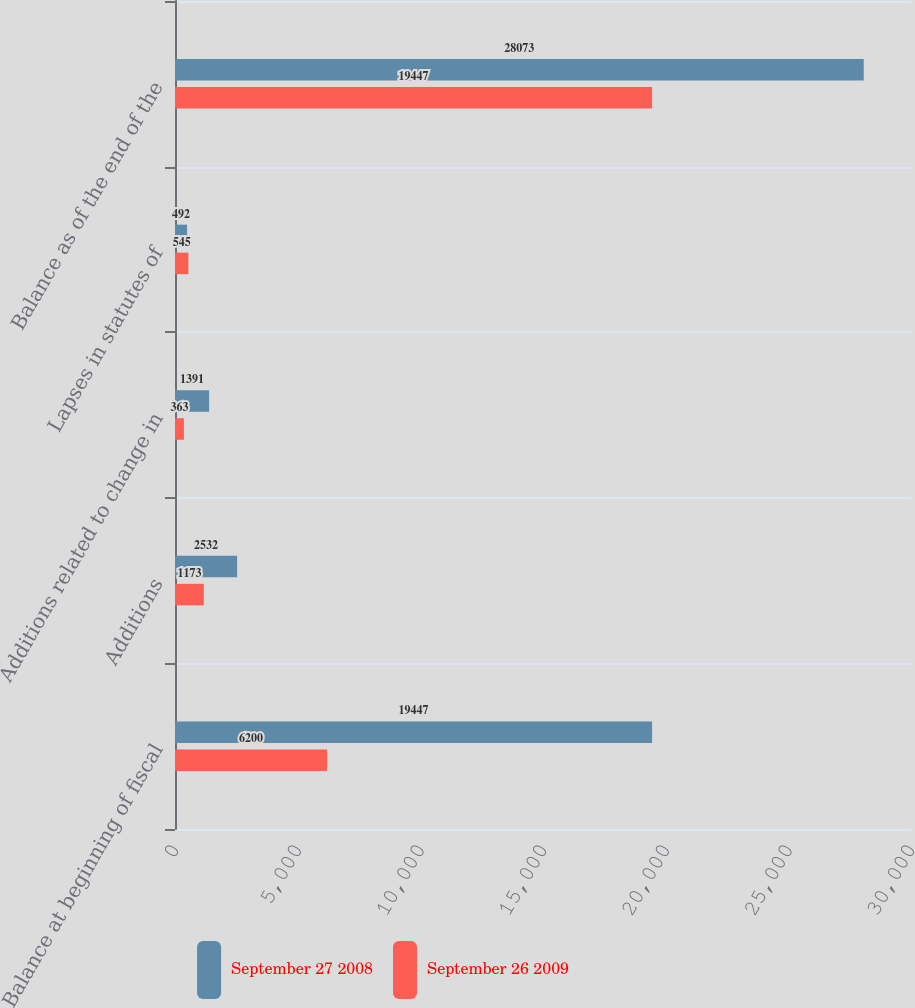Convert chart. <chart><loc_0><loc_0><loc_500><loc_500><stacked_bar_chart><ecel><fcel>Balance at beginning of fiscal<fcel>Additions<fcel>Additions related to change in<fcel>Lapses in statutes of<fcel>Balance as of the end of the<nl><fcel>September 27 2008<fcel>19447<fcel>2532<fcel>1391<fcel>492<fcel>28073<nl><fcel>September 26 2009<fcel>6200<fcel>1173<fcel>363<fcel>545<fcel>19447<nl></chart> 